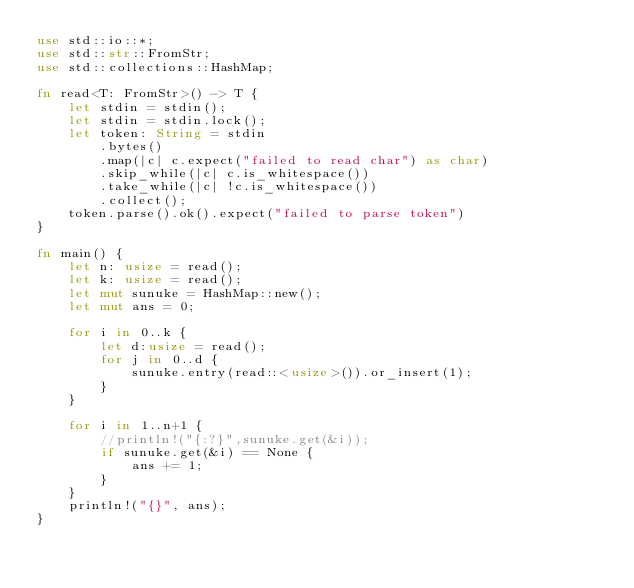Convert code to text. <code><loc_0><loc_0><loc_500><loc_500><_Rust_>use std::io::*;
use std::str::FromStr;
use std::collections::HashMap;

fn read<T: FromStr>() -> T {
    let stdin = stdin();
    let stdin = stdin.lock();
    let token: String = stdin
        .bytes()
        .map(|c| c.expect("failed to read char") as char)
        .skip_while(|c| c.is_whitespace())
        .take_while(|c| !c.is_whitespace())
        .collect();
    token.parse().ok().expect("failed to parse token")
}

fn main() {
    let n: usize = read();
    let k: usize = read();
    let mut sunuke = HashMap::new();
    let mut ans = 0;

    for i in 0..k {
        let d:usize = read();
        for j in 0..d {
            sunuke.entry(read::<usize>()).or_insert(1);
        }
    }

    for i in 1..n+1 {
        //println!("{:?}",sunuke.get(&i));
        if sunuke.get(&i) == None {
            ans += 1;
        }
    }
    println!("{}", ans);
}
</code> 